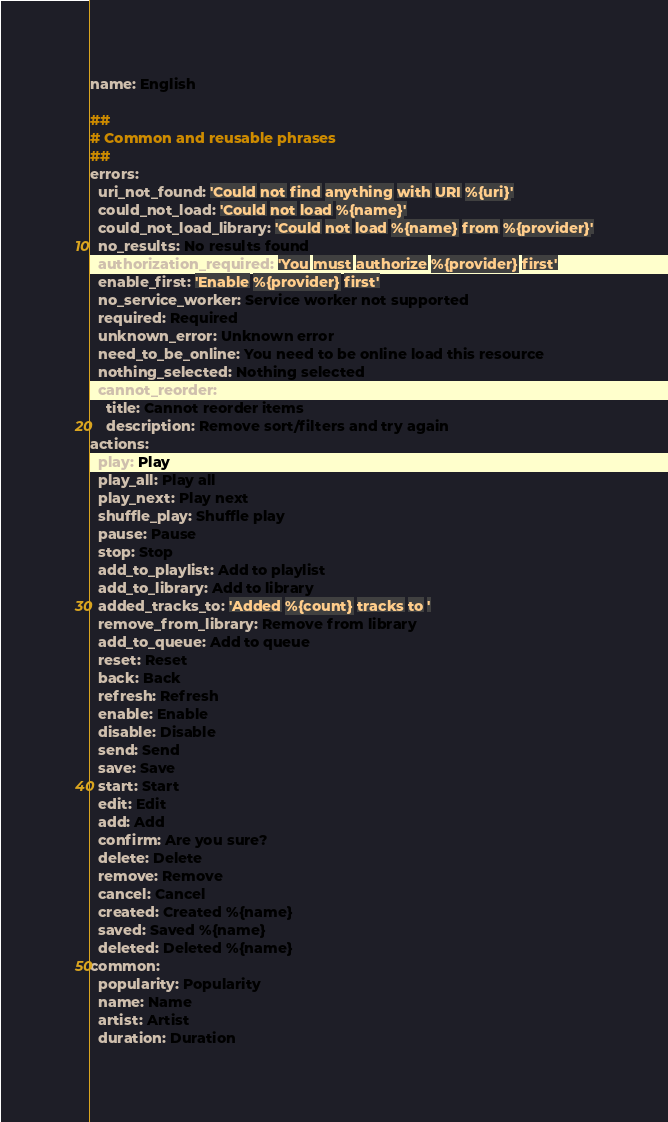<code> <loc_0><loc_0><loc_500><loc_500><_YAML_>name: English

##
# Common and reusable phrases
##
errors:
  uri_not_found: 'Could not find anything with URI %{uri}'
  could_not_load: 'Could not load %{name}'
  could_not_load_library: 'Could not load %{name} from %{provider}'
  no_results: No results found
  authorization_required: 'You must authorize %{provider} first'
  enable_first: 'Enable %{provider} first'
  no_service_worker: Service worker not supported
  required: Required
  unknown_error: Unknown error
  need_to_be_online: You need to be online load this resource
  nothing_selected: Nothing selected
  cannot_reorder:
    title: Cannot reorder items
    description: Remove sort/filters and try again
actions:
  play: Play
  play_all: Play all
  play_next: Play next
  shuffle_play: Shuffle play
  pause: Pause
  stop: Stop
  add_to_playlist: Add to playlist
  add_to_library: Add to library
  added_tracks_to: 'Added %{count} tracks to '
  remove_from_library: Remove from library
  add_to_queue: Add to queue
  reset: Reset
  back: Back
  refresh: Refresh
  enable: Enable
  disable: Disable
  send: Send
  save: Save
  start: Start
  edit: Edit
  add: Add
  confirm: Are you sure?
  delete: Delete
  remove: Remove
  cancel: Cancel
  created: Created %{name}
  saved: Saved %{name}
  deleted: Deleted %{name}
common:
  popularity: Popularity
  name: Name
  artist: Artist
  duration: Duration</code> 